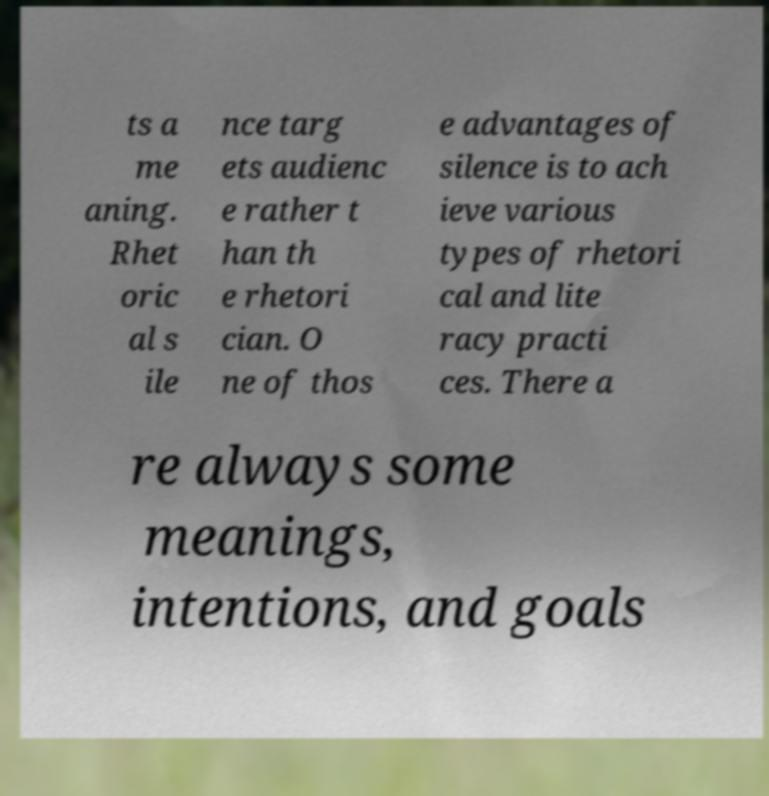There's text embedded in this image that I need extracted. Can you transcribe it verbatim? ts a me aning. Rhet oric al s ile nce targ ets audienc e rather t han th e rhetori cian. O ne of thos e advantages of silence is to ach ieve various types of rhetori cal and lite racy practi ces. There a re always some meanings, intentions, and goals 